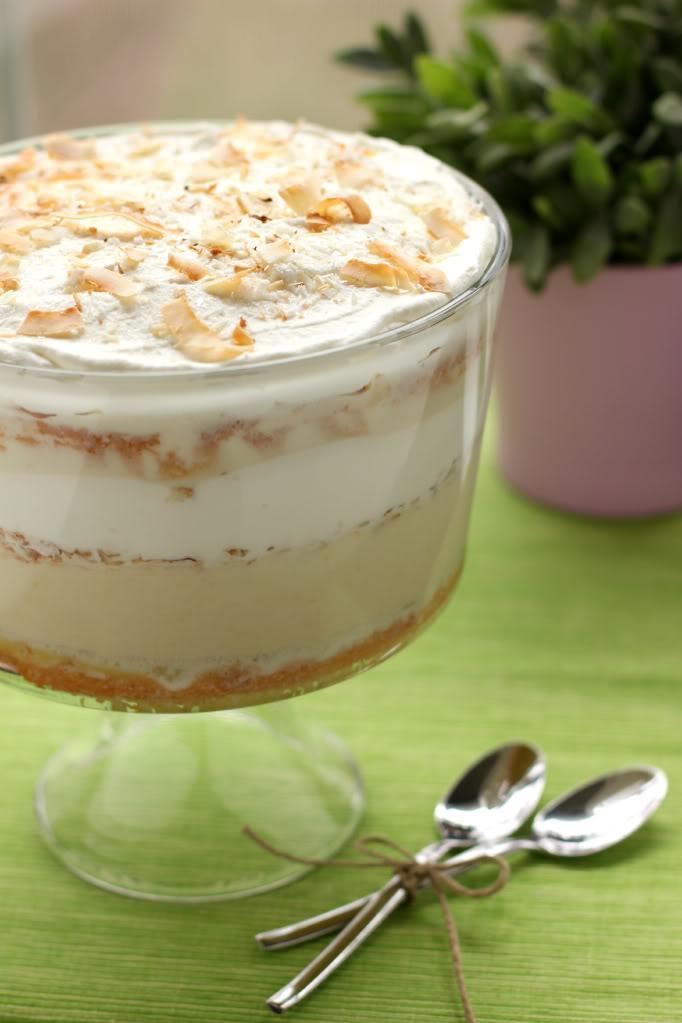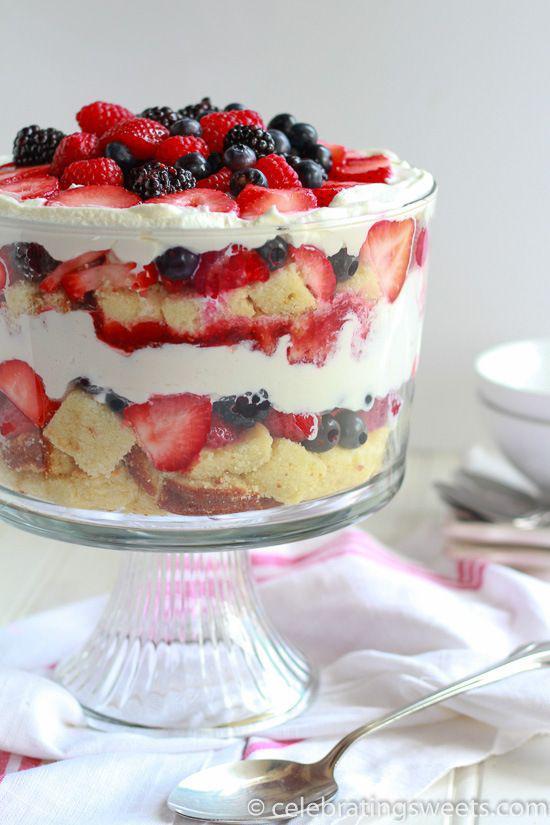The first image is the image on the left, the second image is the image on the right. For the images shown, is this caption "Berries top a trifle in one image." true? Answer yes or no. Yes. 